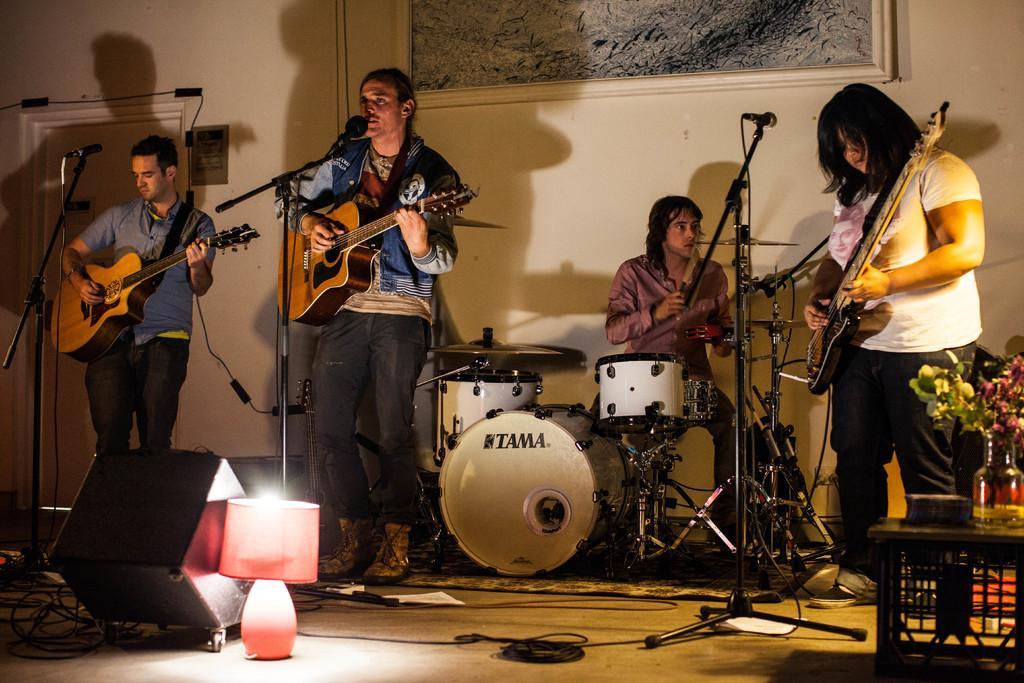Can you describe this image briefly? In the picture we can find a three people standing, two men and one woman, just beside to them there is one person sitting on a chair and playing a drums. The three people who are standing are holding a guitar and singing a song in the microphones. In the background we can find a wall and a painting, And on the floor we can also find a lamp, music box, wires and some plants. 